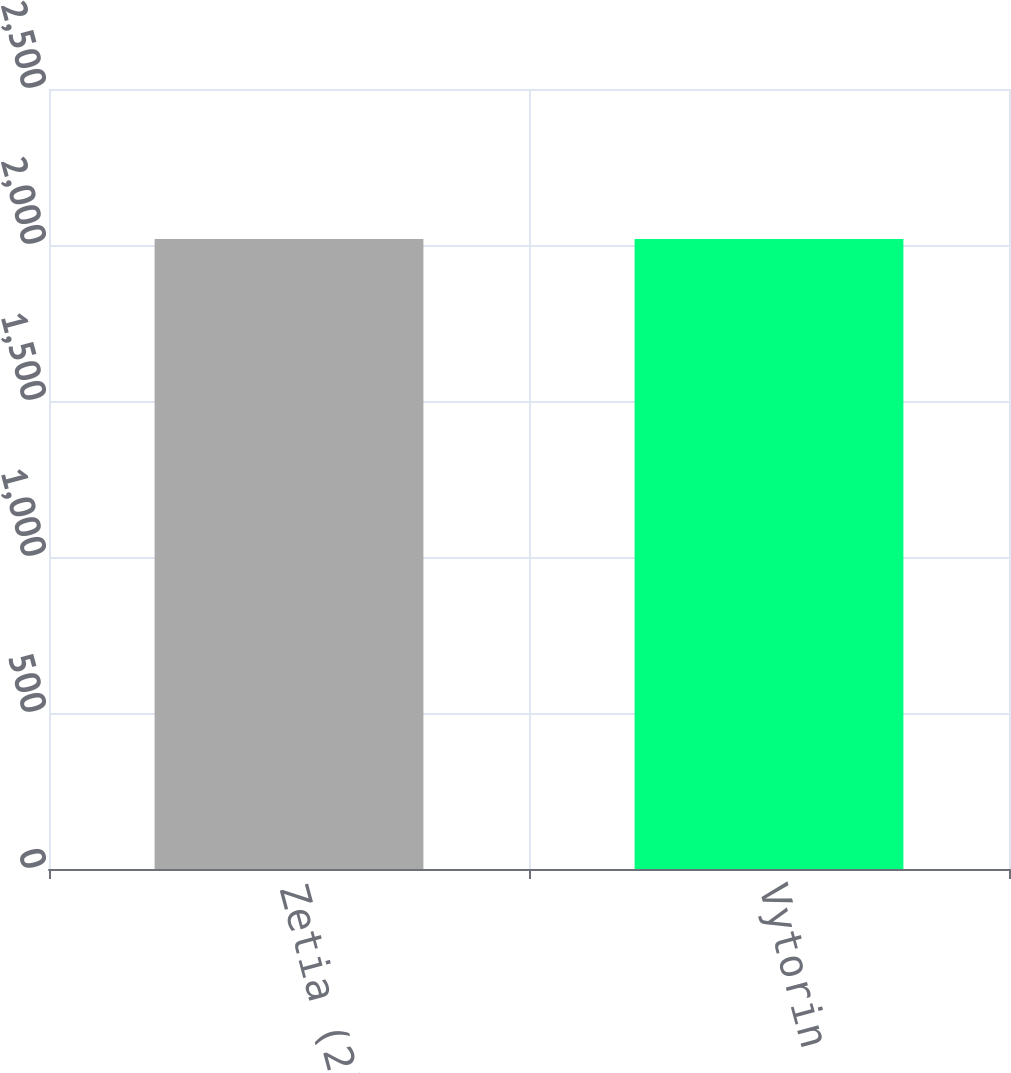Convert chart. <chart><loc_0><loc_0><loc_500><loc_500><bar_chart><fcel>Zetia (2)<fcel>Vytorin<nl><fcel>2019<fcel>2019.1<nl></chart> 